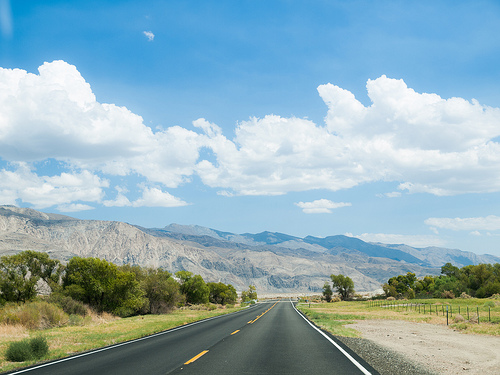<image>
Can you confirm if the tree is to the right of the road? No. The tree is not to the right of the road. The horizontal positioning shows a different relationship. 